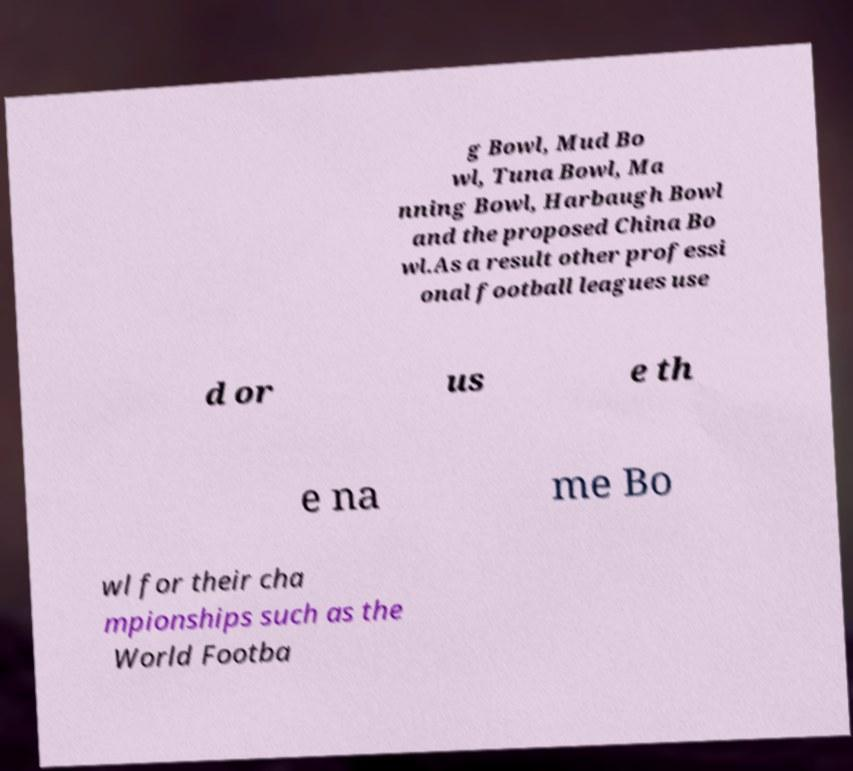What messages or text are displayed in this image? I need them in a readable, typed format. g Bowl, Mud Bo wl, Tuna Bowl, Ma nning Bowl, Harbaugh Bowl and the proposed China Bo wl.As a result other professi onal football leagues use d or us e th e na me Bo wl for their cha mpionships such as the World Footba 